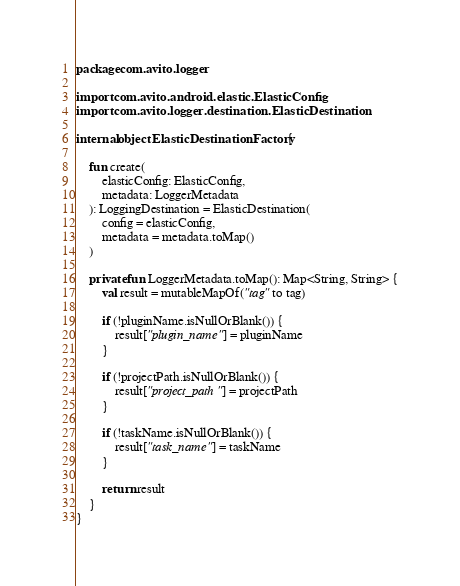<code> <loc_0><loc_0><loc_500><loc_500><_Kotlin_>package com.avito.logger

import com.avito.android.elastic.ElasticConfig
import com.avito.logger.destination.ElasticDestination

internal object ElasticDestinationFactory {

    fun create(
        elasticConfig: ElasticConfig,
        metadata: LoggerMetadata
    ): LoggingDestination = ElasticDestination(
        config = elasticConfig,
        metadata = metadata.toMap()
    )

    private fun LoggerMetadata.toMap(): Map<String, String> {
        val result = mutableMapOf("tag" to tag)

        if (!pluginName.isNullOrBlank()) {
            result["plugin_name"] = pluginName
        }

        if (!projectPath.isNullOrBlank()) {
            result["project_path"] = projectPath
        }

        if (!taskName.isNullOrBlank()) {
            result["task_name"] = taskName
        }

        return result
    }
}
</code> 